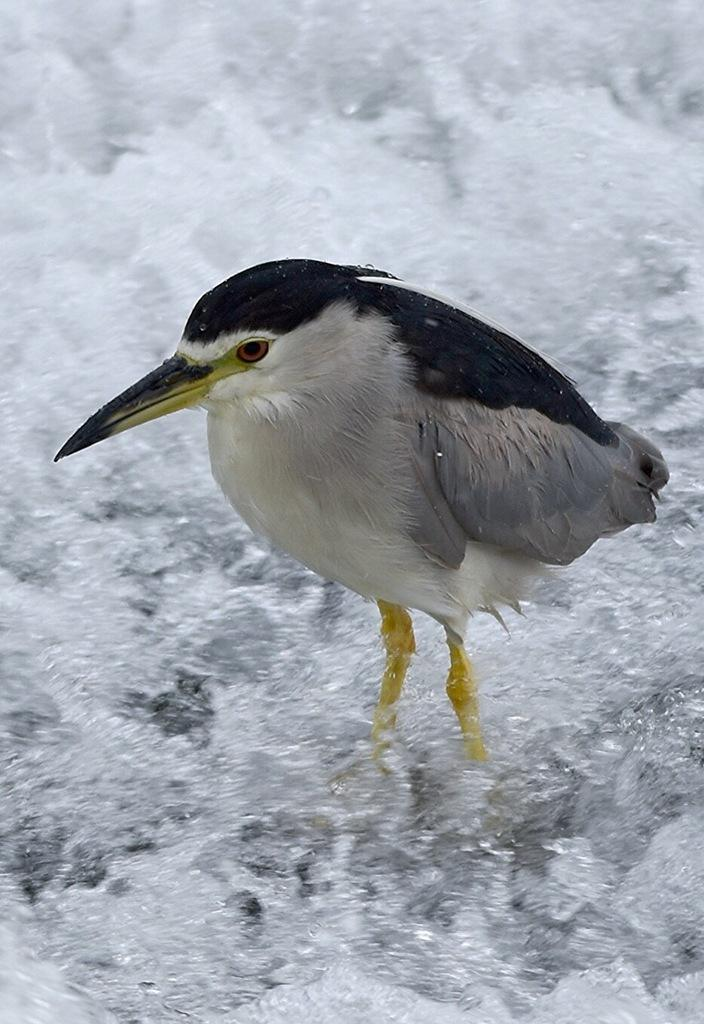What is the color of the object in the image? The object in the image is white and black. What is the object standing on in the image? The object is standing on snow ground in the image. What type of copy is the object holding in the image? There is no copy present in the image, and the object is not holding anything. 